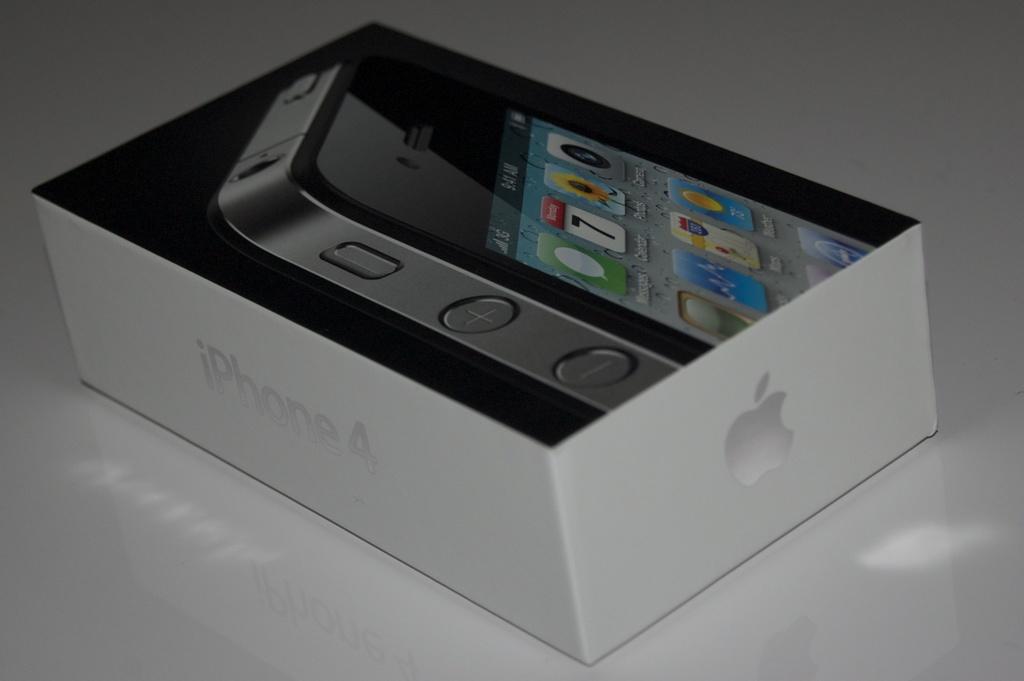What kind of phone is in the packaging?
Provide a short and direct response. Iphone 4. What model iphone is in the box?
Provide a succinct answer. Iphone 4. 